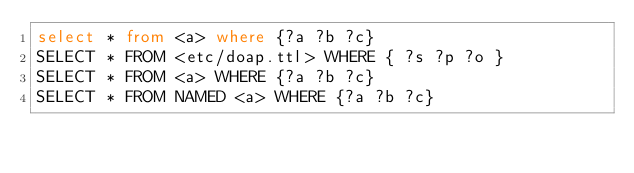Convert code to text. <code><loc_0><loc_0><loc_500><loc_500><_SQL_>select * from <a> where {?a ?b ?c}
SELECT * FROM <etc/doap.ttl> WHERE { ?s ?p ?o }
SELECT * FROM <a> WHERE {?a ?b ?c}
SELECT * FROM NAMED <a> WHERE {?a ?b ?c}
</code> 